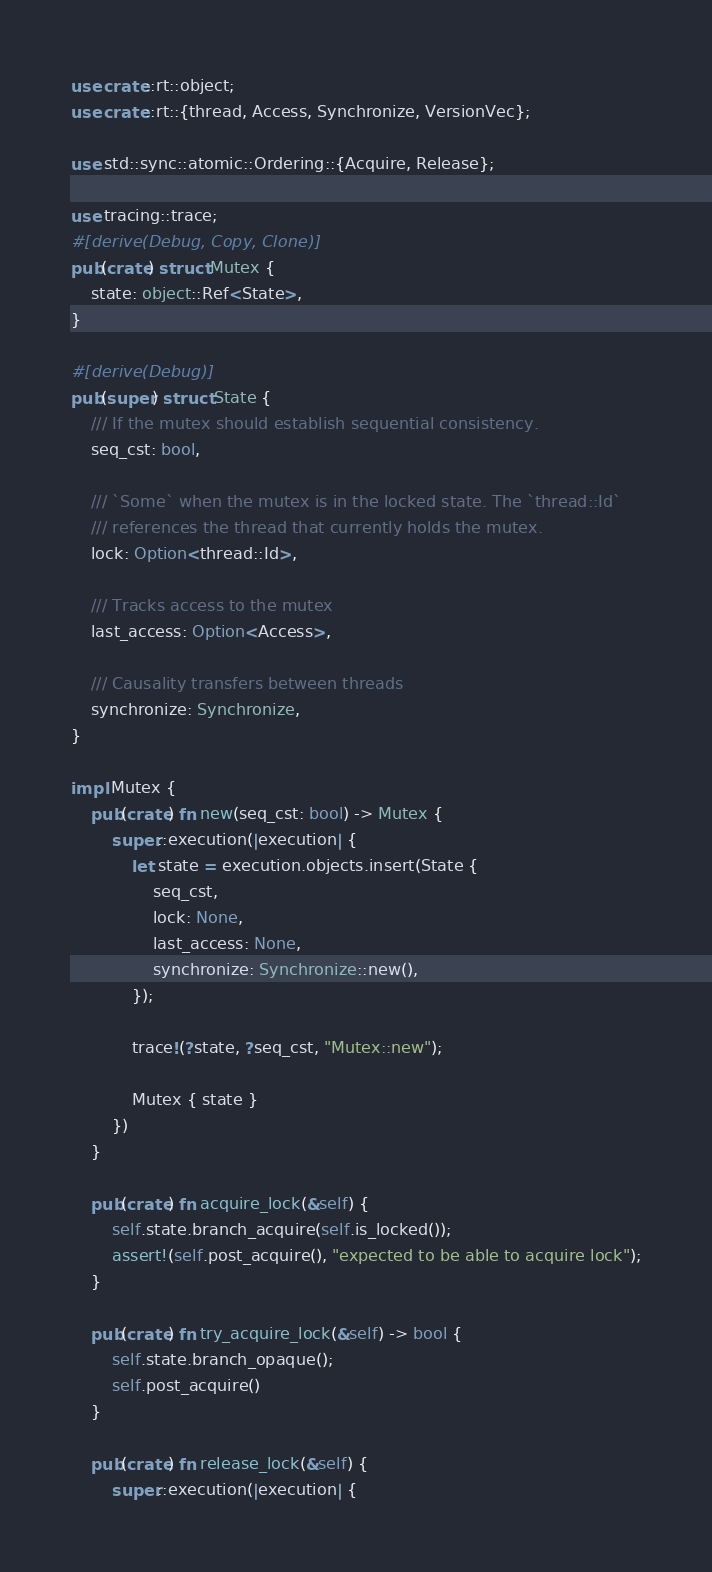<code> <loc_0><loc_0><loc_500><loc_500><_Rust_>use crate::rt::object;
use crate::rt::{thread, Access, Synchronize, VersionVec};

use std::sync::atomic::Ordering::{Acquire, Release};

use tracing::trace;
#[derive(Debug, Copy, Clone)]
pub(crate) struct Mutex {
    state: object::Ref<State>,
}

#[derive(Debug)]
pub(super) struct State {
    /// If the mutex should establish sequential consistency.
    seq_cst: bool,

    /// `Some` when the mutex is in the locked state. The `thread::Id`
    /// references the thread that currently holds the mutex.
    lock: Option<thread::Id>,

    /// Tracks access to the mutex
    last_access: Option<Access>,

    /// Causality transfers between threads
    synchronize: Synchronize,
}

impl Mutex {
    pub(crate) fn new(seq_cst: bool) -> Mutex {
        super::execution(|execution| {
            let state = execution.objects.insert(State {
                seq_cst,
                lock: None,
                last_access: None,
                synchronize: Synchronize::new(),
            });

            trace!(?state, ?seq_cst, "Mutex::new");

            Mutex { state }
        })
    }

    pub(crate) fn acquire_lock(&self) {
        self.state.branch_acquire(self.is_locked());
        assert!(self.post_acquire(), "expected to be able to acquire lock");
    }

    pub(crate) fn try_acquire_lock(&self) -> bool {
        self.state.branch_opaque();
        self.post_acquire()
    }

    pub(crate) fn release_lock(&self) {
        super::execution(|execution| {</code> 